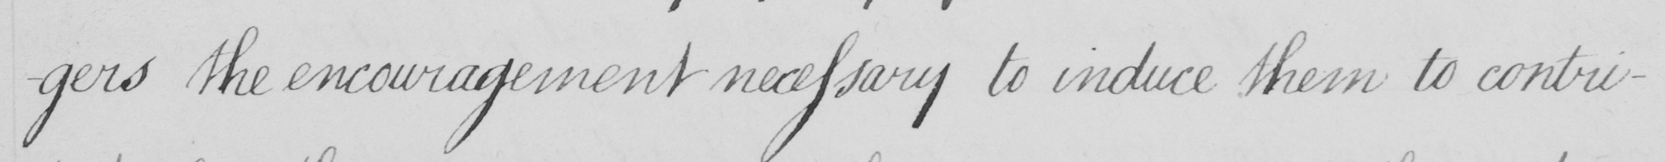What text is written in this handwritten line? -gers the encouragement necessary to induce them to contri- 